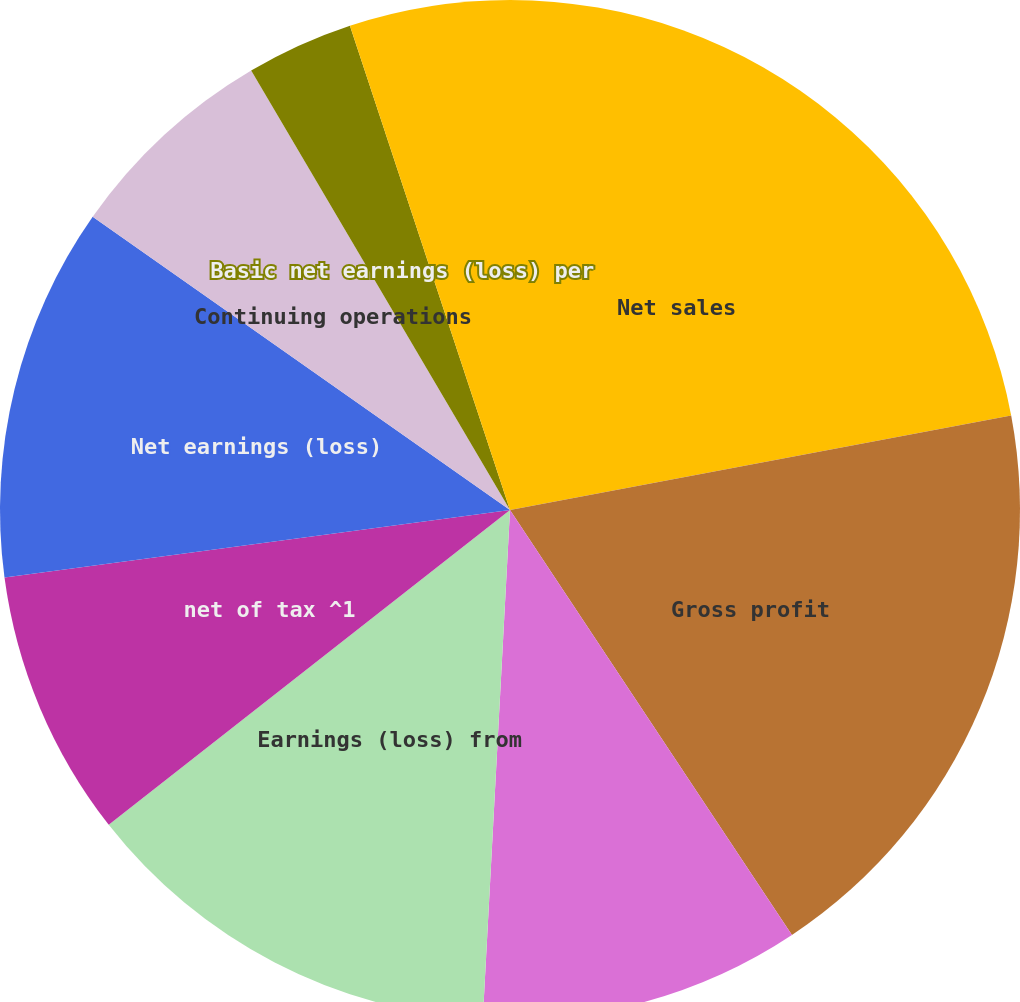Convert chart. <chart><loc_0><loc_0><loc_500><loc_500><pie_chart><fcel>Net sales<fcel>Gross profit<fcel>Gross profit as a percentage<fcel>Earnings (loss) from<fcel>net of tax ^1<fcel>Net earnings (loss)<fcel>Continuing operations<fcel>Discontinued operations<fcel>Basic net earnings (loss) per<fcel>Diluted net earnings (loss)<nl><fcel>22.03%<fcel>18.64%<fcel>10.17%<fcel>13.56%<fcel>8.47%<fcel>11.86%<fcel>6.78%<fcel>0.0%<fcel>3.39%<fcel>5.08%<nl></chart> 